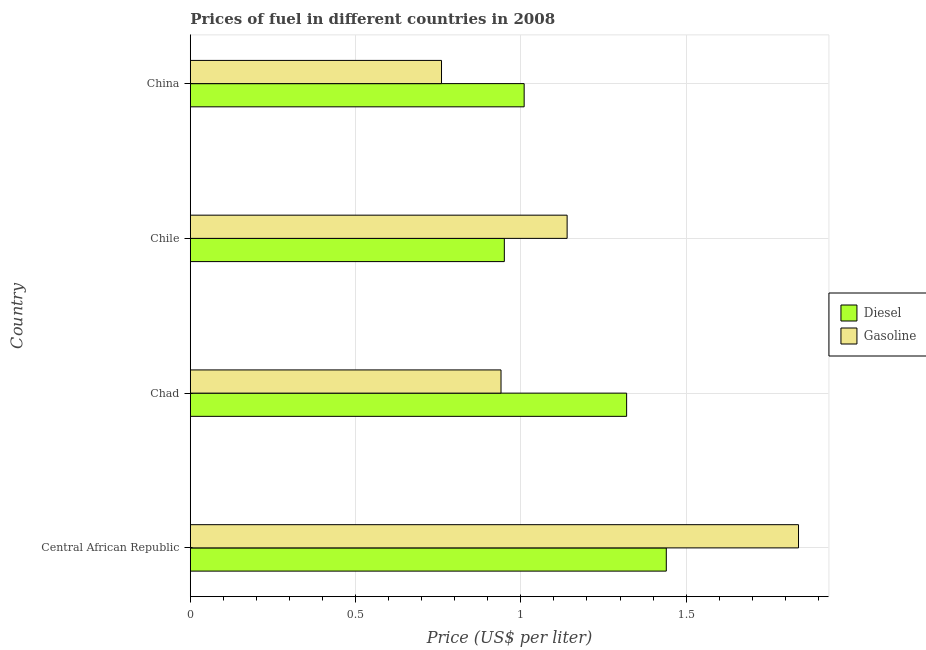Are the number of bars per tick equal to the number of legend labels?
Offer a very short reply. Yes. What is the label of the 4th group of bars from the top?
Your response must be concise. Central African Republic. What is the gasoline price in Central African Republic?
Your answer should be compact. 1.84. Across all countries, what is the maximum diesel price?
Offer a very short reply. 1.44. Across all countries, what is the minimum gasoline price?
Provide a succinct answer. 0.76. In which country was the diesel price maximum?
Your answer should be compact. Central African Republic. What is the total diesel price in the graph?
Keep it short and to the point. 4.72. What is the difference between the diesel price in Central African Republic and the gasoline price in Chile?
Provide a succinct answer. 0.3. What is the average gasoline price per country?
Your answer should be very brief. 1.17. What is the difference between the gasoline price and diesel price in Central African Republic?
Provide a succinct answer. 0.4. What is the ratio of the gasoline price in Central African Republic to that in Chad?
Ensure brevity in your answer.  1.96. Is the difference between the gasoline price in Central African Republic and Chad greater than the difference between the diesel price in Central African Republic and Chad?
Offer a very short reply. Yes. What is the difference between the highest and the second highest gasoline price?
Give a very brief answer. 0.7. Is the sum of the gasoline price in Central African Republic and Chad greater than the maximum diesel price across all countries?
Ensure brevity in your answer.  Yes. What does the 2nd bar from the top in Chad represents?
Offer a very short reply. Diesel. What does the 2nd bar from the bottom in Central African Republic represents?
Keep it short and to the point. Gasoline. How many bars are there?
Give a very brief answer. 8. Are all the bars in the graph horizontal?
Make the answer very short. Yes. How many countries are there in the graph?
Your response must be concise. 4. What is the difference between two consecutive major ticks on the X-axis?
Keep it short and to the point. 0.5. Are the values on the major ticks of X-axis written in scientific E-notation?
Offer a terse response. No. Does the graph contain grids?
Provide a short and direct response. Yes. Where does the legend appear in the graph?
Offer a very short reply. Center right. What is the title of the graph?
Offer a very short reply. Prices of fuel in different countries in 2008. Does "Merchandise exports" appear as one of the legend labels in the graph?
Keep it short and to the point. No. What is the label or title of the X-axis?
Provide a short and direct response. Price (US$ per liter). What is the label or title of the Y-axis?
Provide a short and direct response. Country. What is the Price (US$ per liter) in Diesel in Central African Republic?
Offer a very short reply. 1.44. What is the Price (US$ per liter) of Gasoline in Central African Republic?
Provide a succinct answer. 1.84. What is the Price (US$ per liter) in Diesel in Chad?
Offer a terse response. 1.32. What is the Price (US$ per liter) of Gasoline in Chad?
Provide a succinct answer. 0.94. What is the Price (US$ per liter) of Gasoline in Chile?
Your answer should be very brief. 1.14. What is the Price (US$ per liter) of Gasoline in China?
Provide a succinct answer. 0.76. Across all countries, what is the maximum Price (US$ per liter) of Diesel?
Give a very brief answer. 1.44. Across all countries, what is the maximum Price (US$ per liter) in Gasoline?
Your answer should be very brief. 1.84. Across all countries, what is the minimum Price (US$ per liter) of Gasoline?
Ensure brevity in your answer.  0.76. What is the total Price (US$ per liter) in Diesel in the graph?
Provide a short and direct response. 4.72. What is the total Price (US$ per liter) in Gasoline in the graph?
Your response must be concise. 4.68. What is the difference between the Price (US$ per liter) in Diesel in Central African Republic and that in Chad?
Your answer should be very brief. 0.12. What is the difference between the Price (US$ per liter) in Gasoline in Central African Republic and that in Chad?
Give a very brief answer. 0.9. What is the difference between the Price (US$ per liter) of Diesel in Central African Republic and that in Chile?
Provide a succinct answer. 0.49. What is the difference between the Price (US$ per liter) of Gasoline in Central African Republic and that in Chile?
Give a very brief answer. 0.7. What is the difference between the Price (US$ per liter) in Diesel in Central African Republic and that in China?
Your answer should be compact. 0.43. What is the difference between the Price (US$ per liter) in Diesel in Chad and that in Chile?
Make the answer very short. 0.37. What is the difference between the Price (US$ per liter) of Gasoline in Chad and that in Chile?
Provide a succinct answer. -0.2. What is the difference between the Price (US$ per liter) of Diesel in Chad and that in China?
Ensure brevity in your answer.  0.31. What is the difference between the Price (US$ per liter) in Gasoline in Chad and that in China?
Offer a terse response. 0.18. What is the difference between the Price (US$ per liter) in Diesel in Chile and that in China?
Offer a terse response. -0.06. What is the difference between the Price (US$ per liter) in Gasoline in Chile and that in China?
Your answer should be compact. 0.38. What is the difference between the Price (US$ per liter) of Diesel in Central African Republic and the Price (US$ per liter) of Gasoline in Chad?
Keep it short and to the point. 0.5. What is the difference between the Price (US$ per liter) in Diesel in Central African Republic and the Price (US$ per liter) in Gasoline in Chile?
Provide a succinct answer. 0.3. What is the difference between the Price (US$ per liter) of Diesel in Central African Republic and the Price (US$ per liter) of Gasoline in China?
Offer a terse response. 0.68. What is the difference between the Price (US$ per liter) in Diesel in Chad and the Price (US$ per liter) in Gasoline in Chile?
Your answer should be very brief. 0.18. What is the difference between the Price (US$ per liter) of Diesel in Chad and the Price (US$ per liter) of Gasoline in China?
Your answer should be very brief. 0.56. What is the difference between the Price (US$ per liter) in Diesel in Chile and the Price (US$ per liter) in Gasoline in China?
Provide a short and direct response. 0.19. What is the average Price (US$ per liter) in Diesel per country?
Provide a short and direct response. 1.18. What is the average Price (US$ per liter) in Gasoline per country?
Your response must be concise. 1.17. What is the difference between the Price (US$ per liter) of Diesel and Price (US$ per liter) of Gasoline in Chad?
Offer a very short reply. 0.38. What is the difference between the Price (US$ per liter) in Diesel and Price (US$ per liter) in Gasoline in Chile?
Your answer should be very brief. -0.19. What is the ratio of the Price (US$ per liter) in Diesel in Central African Republic to that in Chad?
Provide a succinct answer. 1.09. What is the ratio of the Price (US$ per liter) in Gasoline in Central African Republic to that in Chad?
Offer a terse response. 1.96. What is the ratio of the Price (US$ per liter) in Diesel in Central African Republic to that in Chile?
Offer a terse response. 1.52. What is the ratio of the Price (US$ per liter) in Gasoline in Central African Republic to that in Chile?
Keep it short and to the point. 1.61. What is the ratio of the Price (US$ per liter) of Diesel in Central African Republic to that in China?
Provide a succinct answer. 1.43. What is the ratio of the Price (US$ per liter) of Gasoline in Central African Republic to that in China?
Your answer should be compact. 2.42. What is the ratio of the Price (US$ per liter) in Diesel in Chad to that in Chile?
Provide a short and direct response. 1.39. What is the ratio of the Price (US$ per liter) in Gasoline in Chad to that in Chile?
Give a very brief answer. 0.82. What is the ratio of the Price (US$ per liter) of Diesel in Chad to that in China?
Ensure brevity in your answer.  1.31. What is the ratio of the Price (US$ per liter) in Gasoline in Chad to that in China?
Give a very brief answer. 1.24. What is the ratio of the Price (US$ per liter) of Diesel in Chile to that in China?
Keep it short and to the point. 0.94. What is the ratio of the Price (US$ per liter) in Gasoline in Chile to that in China?
Provide a short and direct response. 1.5. What is the difference between the highest and the second highest Price (US$ per liter) of Diesel?
Keep it short and to the point. 0.12. What is the difference between the highest and the lowest Price (US$ per liter) of Diesel?
Keep it short and to the point. 0.49. What is the difference between the highest and the lowest Price (US$ per liter) in Gasoline?
Offer a very short reply. 1.08. 